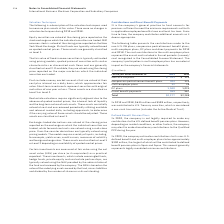According to International Business Machines's financial document, In 2019, what was the amount contributed to US Treasury securities? According to the financial document, $635 million. The relevant text states: "In 2019 and 2018, $635 million and $598 million, respectively, was contributed in U.S. Treasury securities, which is considered a n..." Also, Contribution to US Treasury is considered what kind of a transaction? non-cash transaction. The document states: "n U.S. Treasury securities, which is considered a non-cash transaction (includes the Active Medical Trust)...." Also, What was the Non pension post retirement benefit plan in 2019? According to the financial document, 304 (in millions). The relevant text states: "Nonpension postretirement benefit plans 304 335..." Also, can you calculate: What is the increase / (decrease) in the Non-U.S. DB plans from 2018 to 2019? Based on the calculation: 243 - 325, the result is -82 (in millions). This is based on the information: "Non-U.S. DB plans $ 243 $ 325 Non-U.S. DB plans $ 243 $ 325..." The key data points involved are: 243, 325. Also, can you calculate: What is the average Non pension postretirement benefit plans? To answer this question, I need to perform calculations using the financial data. The calculation is: (304 + 335) / 2, which equals 319.5 (in millions). This is based on the information: "Nonpension postretirement benefit plans 304 335 Nonpension postretirement benefit plans 304 335..." The key data points involved are: 304, 335. Also, can you calculate: What is the percentage increase / (decrease) in the Direct benefit payments from 2018 to 2019? To answer this question, I need to perform calculations using the financial data. The calculation is: 559 / 567 - 1, which equals -1.41 (percentage). This is based on the information: "Direct benefit payments 559 567 Direct benefit payments 559 567..." The key data points involved are: 559, 567. 